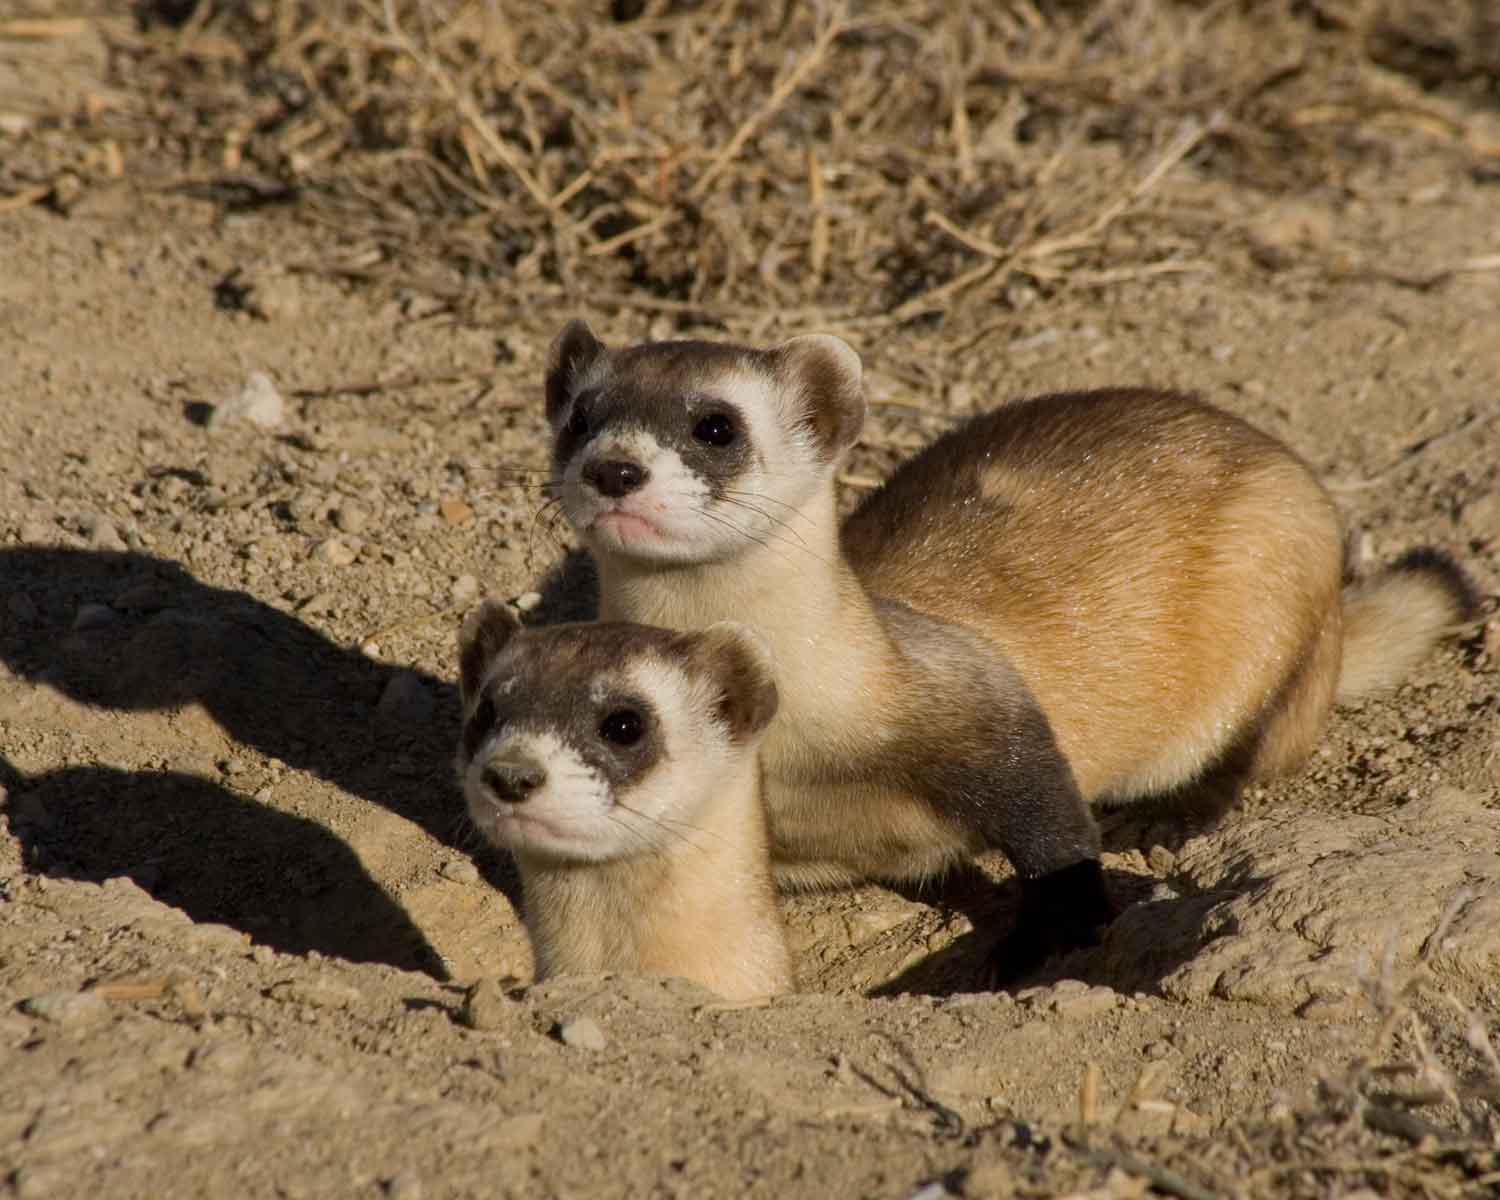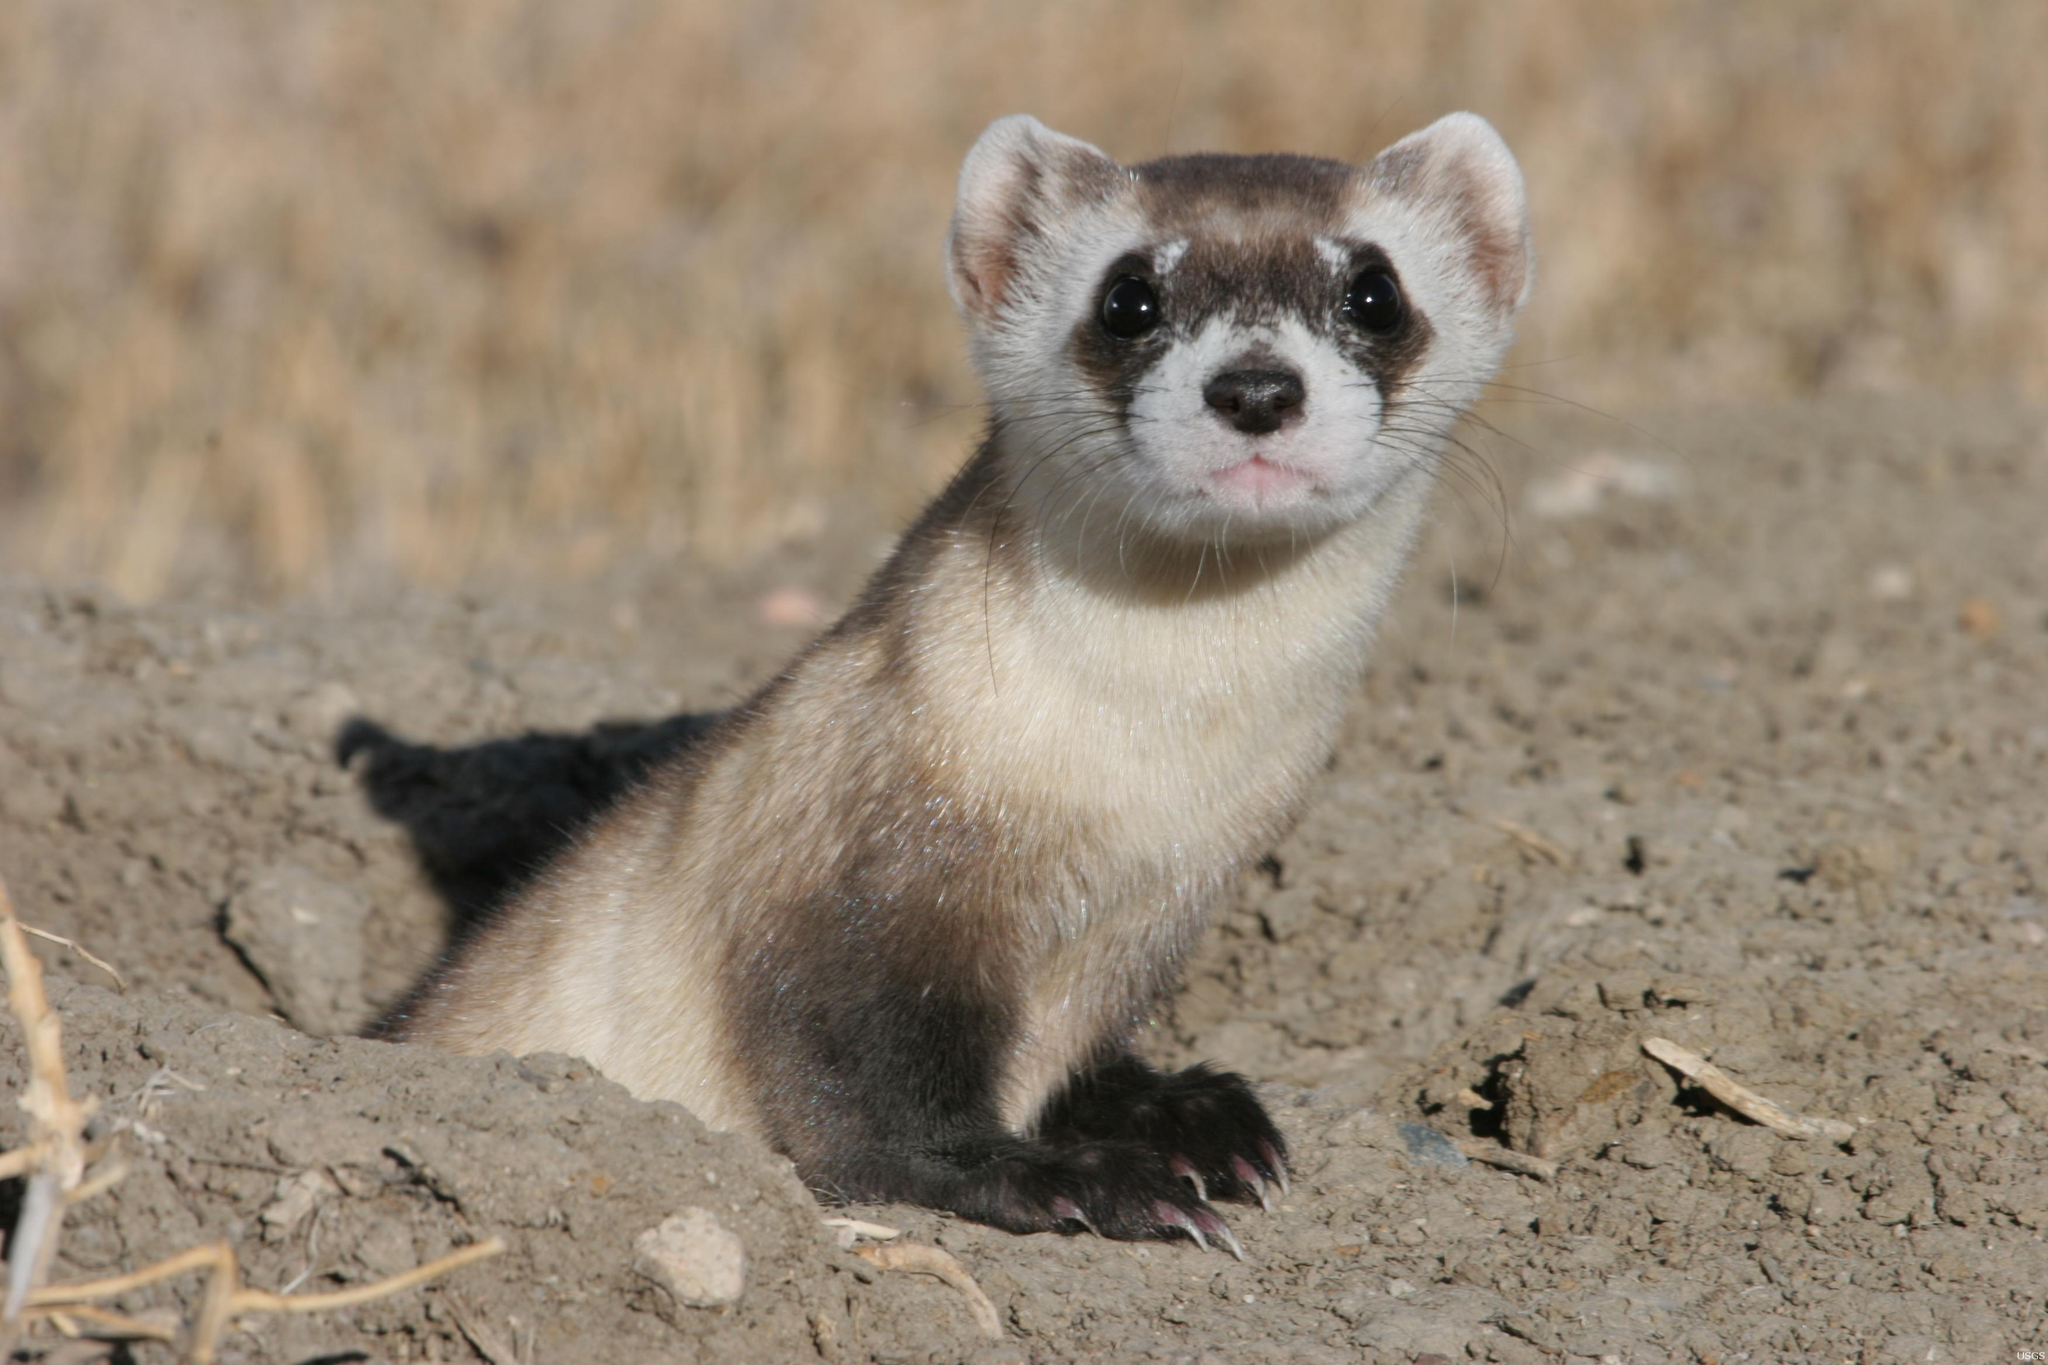The first image is the image on the left, the second image is the image on the right. Examine the images to the left and right. Is the description "At least one of the animals is partly in a hole." accurate? Answer yes or no. Yes. The first image is the image on the left, the second image is the image on the right. Analyze the images presented: Is the assertion "There are no more than two ferrets." valid? Answer yes or no. No. 